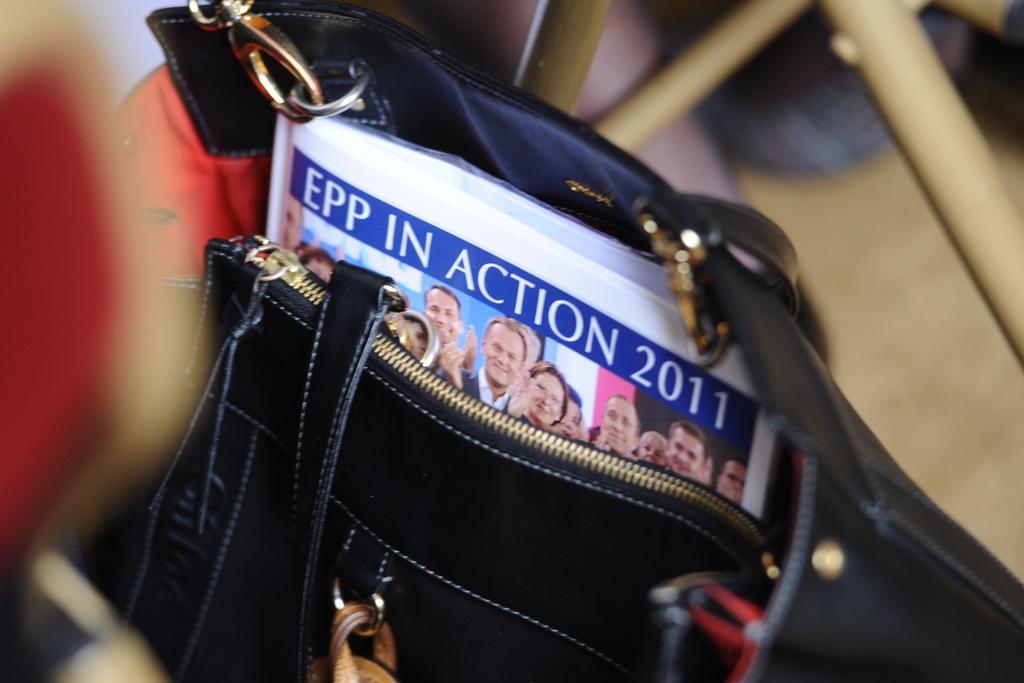How would you summarize this image in a sentence or two? In this picture we can see a bag which is in black color. And there is a book inside the bag. 